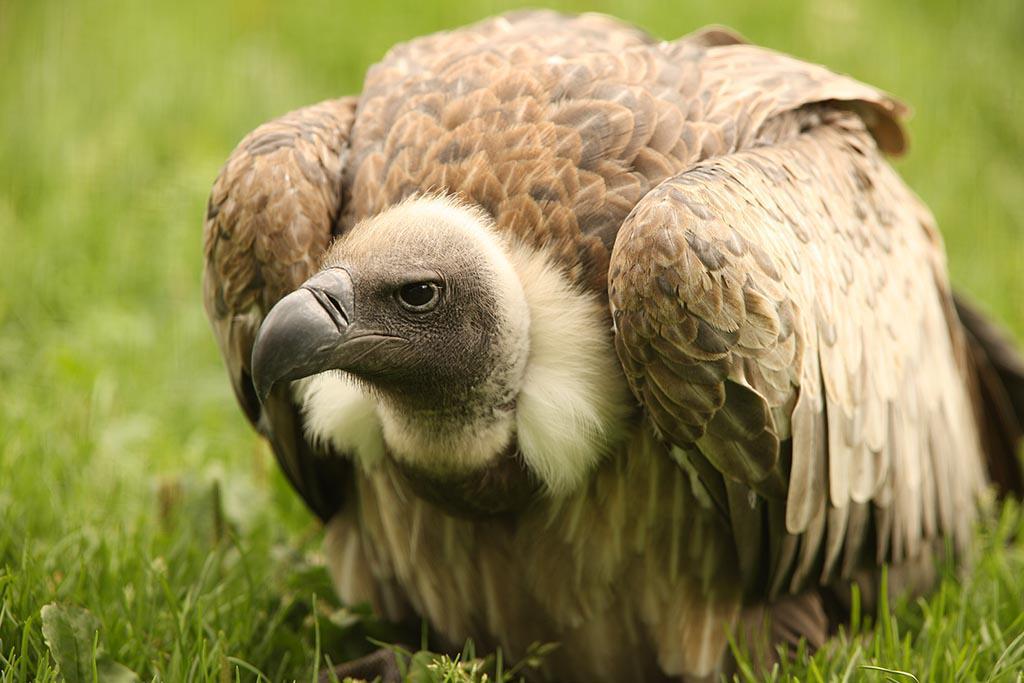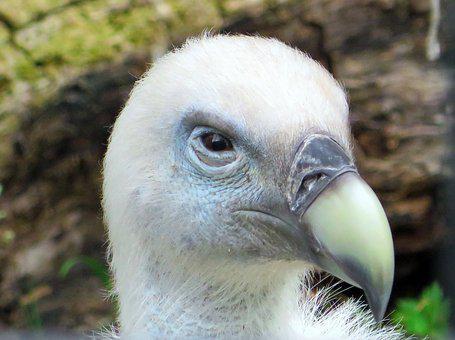The first image is the image on the left, the second image is the image on the right. Analyze the images presented: Is the assertion "The entire bird is visible in the image on the right." valid? Answer yes or no. No. 